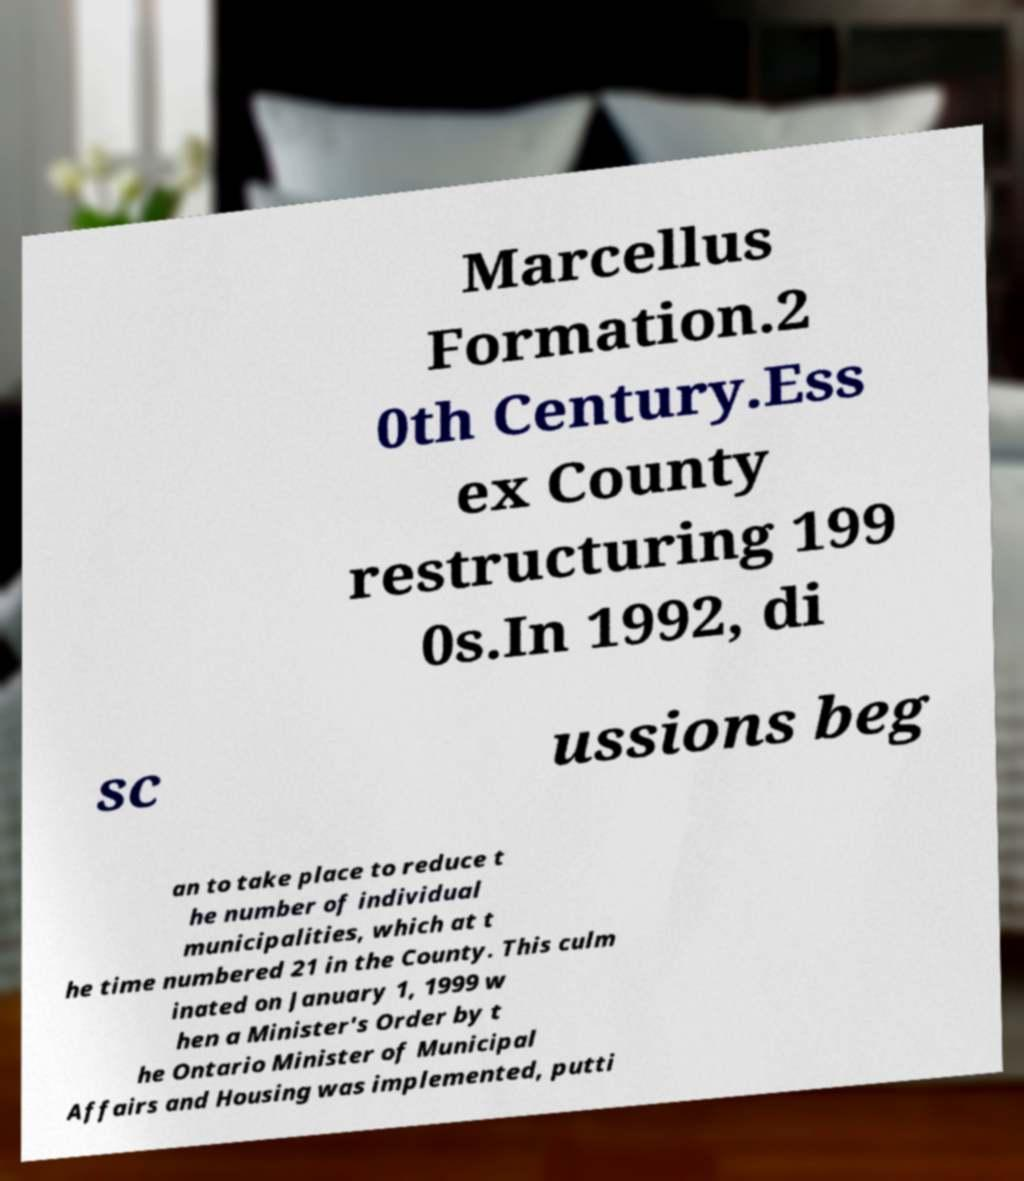What messages or text are displayed in this image? I need them in a readable, typed format. Marcellus Formation.2 0th Century.Ess ex County restructuring 199 0s.In 1992, di sc ussions beg an to take place to reduce t he number of individual municipalities, which at t he time numbered 21 in the County. This culm inated on January 1, 1999 w hen a Minister's Order by t he Ontario Minister of Municipal Affairs and Housing was implemented, putti 